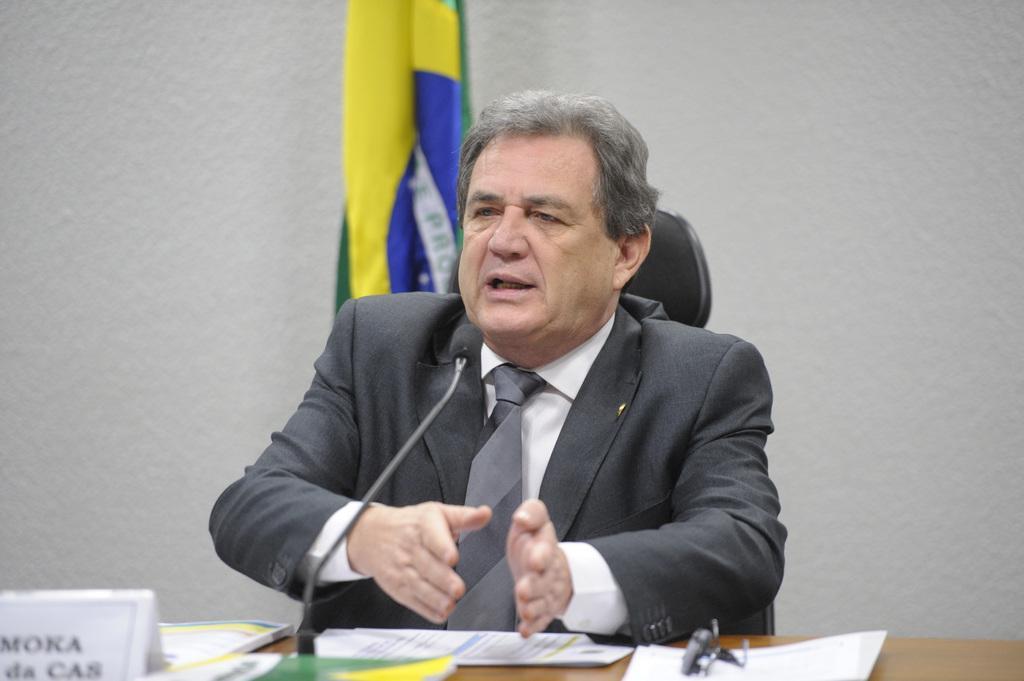Describe this image in one or two sentences. In this image, we can see a man sitting on a chair and there is a table. We can see some papers and a name board on the table. In the background, we can see a flag and we can see the wall. 